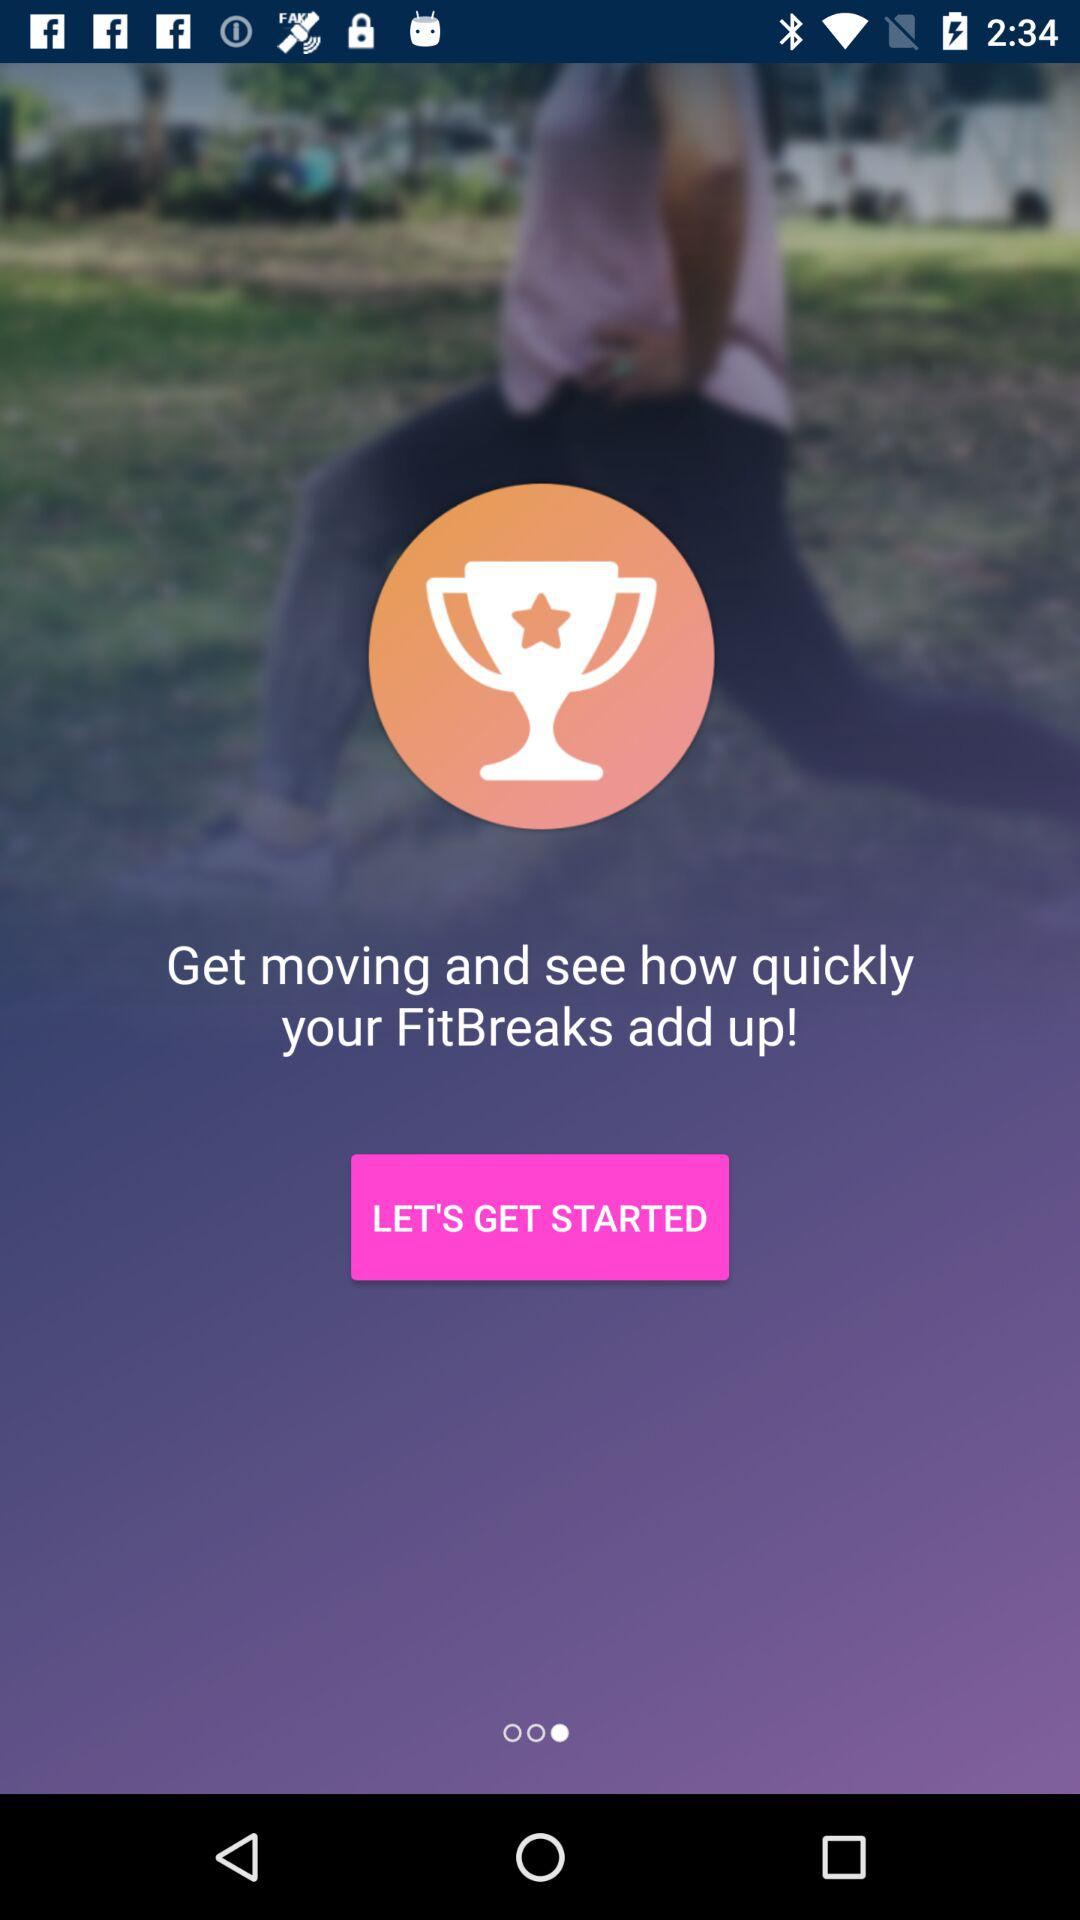What is the application name?
When the provided information is insufficient, respond with <no answer>. <no answer> 